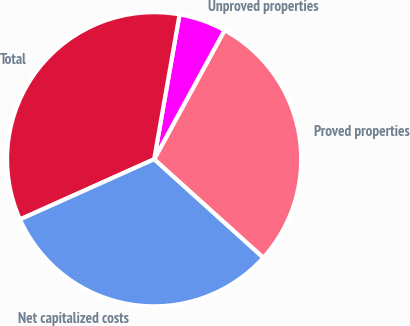Convert chart to OTSL. <chart><loc_0><loc_0><loc_500><loc_500><pie_chart><fcel>Proved properties<fcel>Unproved properties<fcel>Total<fcel>Net capitalized costs<nl><fcel>28.73%<fcel>5.19%<fcel>34.48%<fcel>31.6%<nl></chart> 